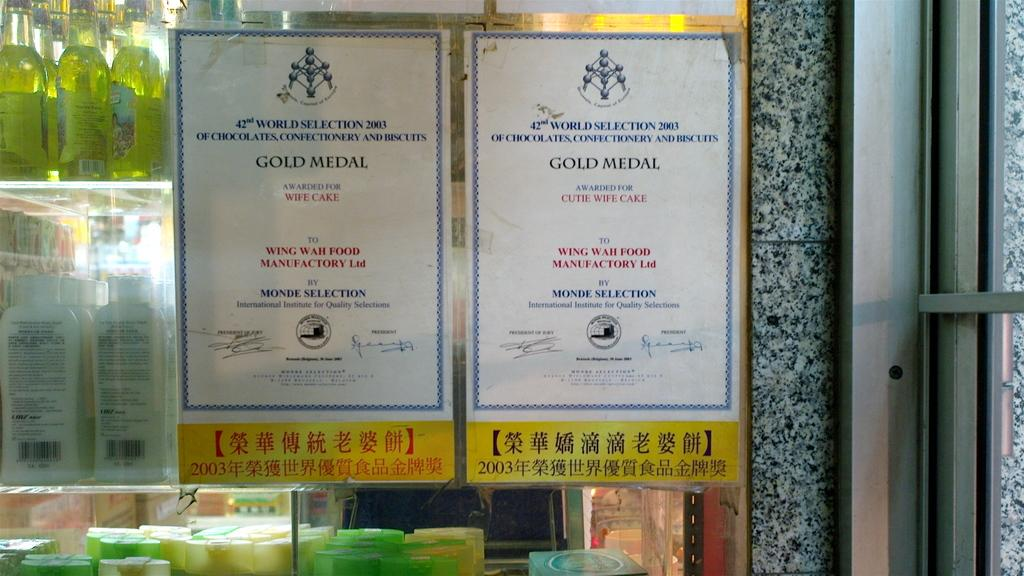<image>
Relay a brief, clear account of the picture shown. Two signs on a window that says Gold Medal. 